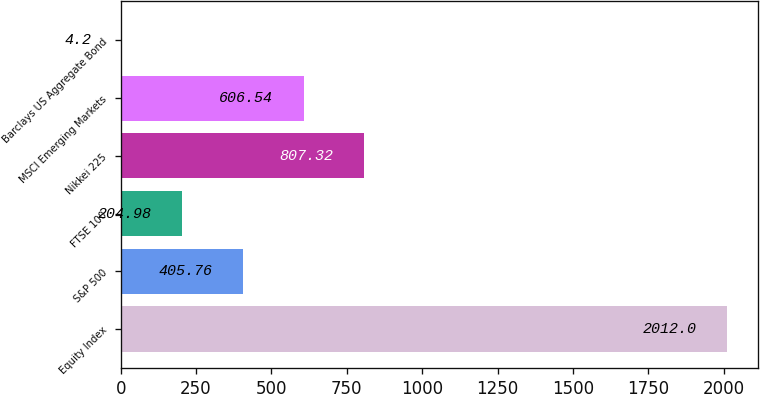<chart> <loc_0><loc_0><loc_500><loc_500><bar_chart><fcel>Equity Index<fcel>S&P 500<fcel>FTSE 100<fcel>Nikkei 225<fcel>MSCI Emerging Markets<fcel>Barclays US Aggregate Bond<nl><fcel>2012<fcel>405.76<fcel>204.98<fcel>807.32<fcel>606.54<fcel>4.2<nl></chart> 